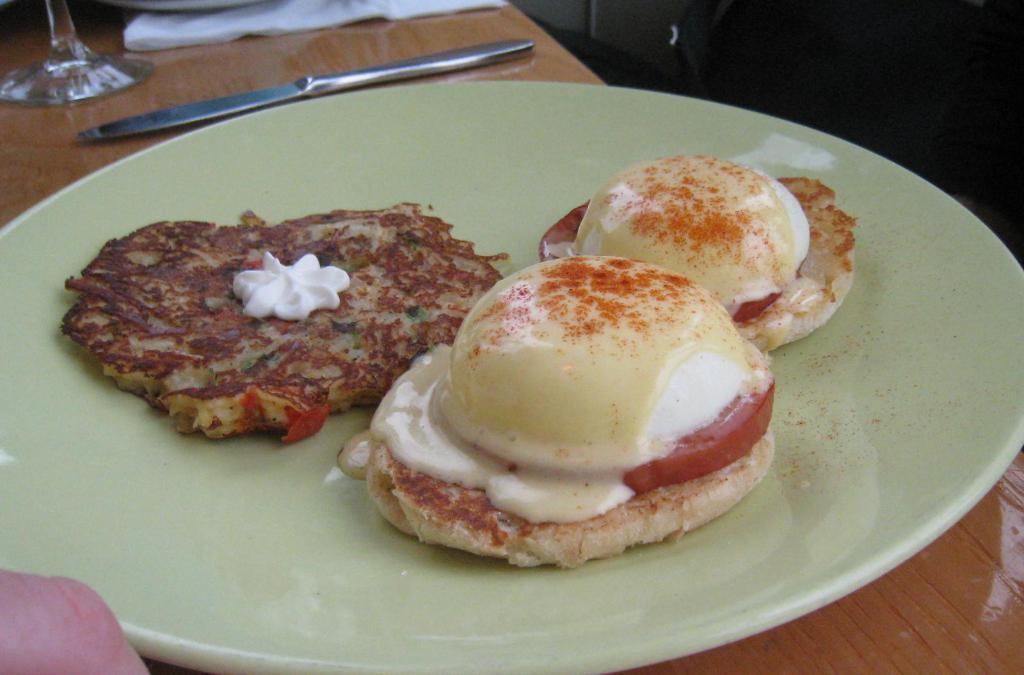How would you summarize this image in a sentence or two? In this image I can see a plate kept on table and on the plate I can see food ,beside the plate I can see knife and glass kept on table and a tissue paper visible at the top on the table. 